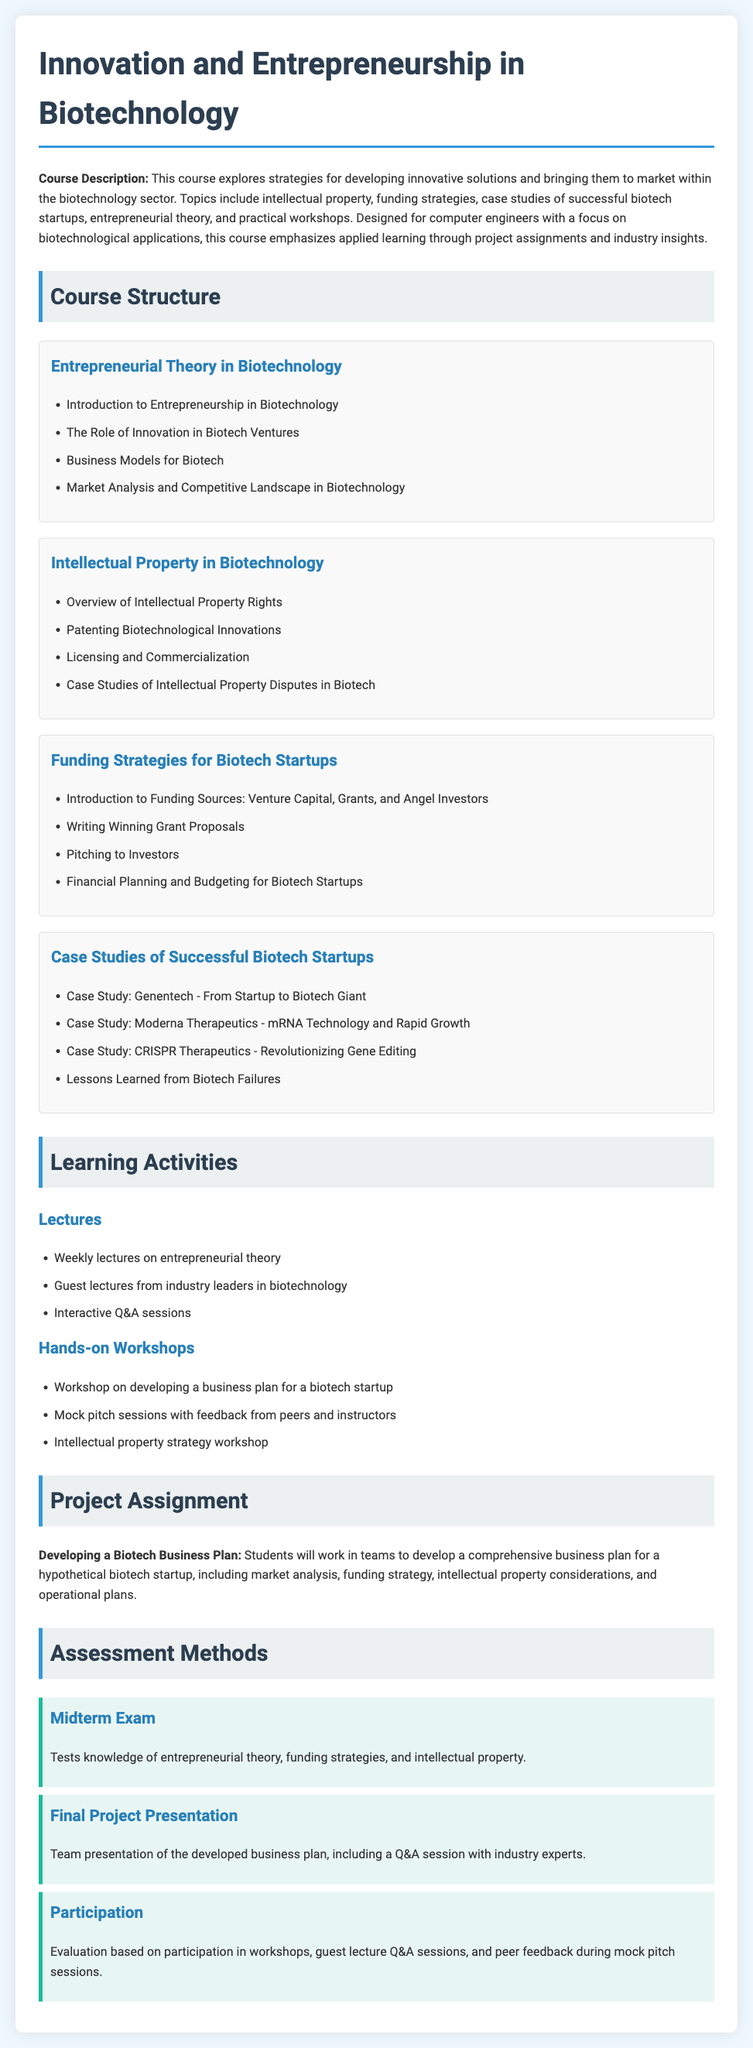What is the course title? The course title is stated in the heading at the top of the document.
Answer: Innovation and Entrepreneurship in Biotechnology What type of students is the course designed for? This detail is mentioned in the course description.
Answer: Computer engineers Name one topic covered in the Intellectual Property module. This information can be found in the list of topics within that module.
Answer: Patenting Biotechnological Innovations How many case studies are presented in the Successful Biotech Startups module? The number of case studies is detailed in the list within that module.
Answer: Four What is the final assessment method mentioned? This is outlined in the Assessment Methods section of the document.
Answer: Final Project Presentation Name one of the funding sources discussed in the Funding Strategies module. This can be found in the list of topics within that module.
Answer: Venture Capital What is the main project assignment for the course? This information is highlighted in the Project Assignment section.
Answer: Developing a Biotech Business Plan What type of sessions will include interactive components? The document describes the format of certain learning activities, indicating this type of session.
Answer: Q&A sessions 